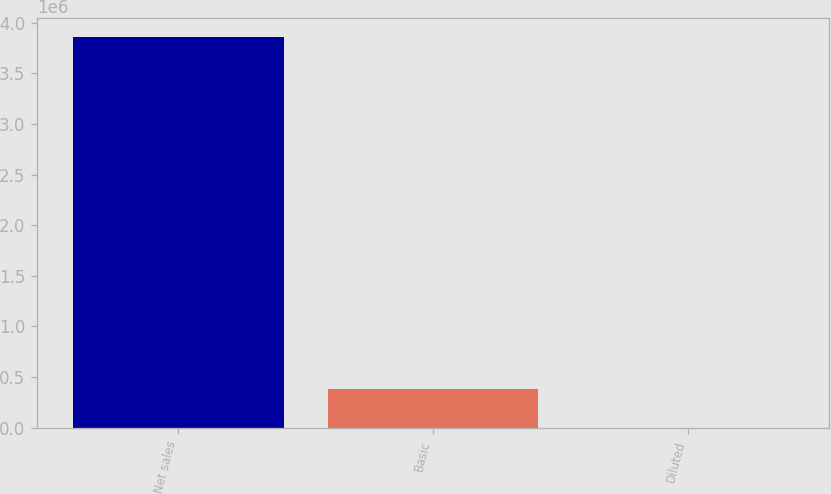Convert chart. <chart><loc_0><loc_0><loc_500><loc_500><bar_chart><fcel>Net sales<fcel>Basic<fcel>Diluted<nl><fcel>3.85759e+06<fcel>385763<fcel>4.06<nl></chart> 